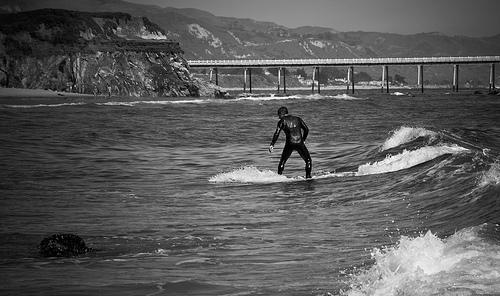How many people are in the photo?
Give a very brief answer. 1. 